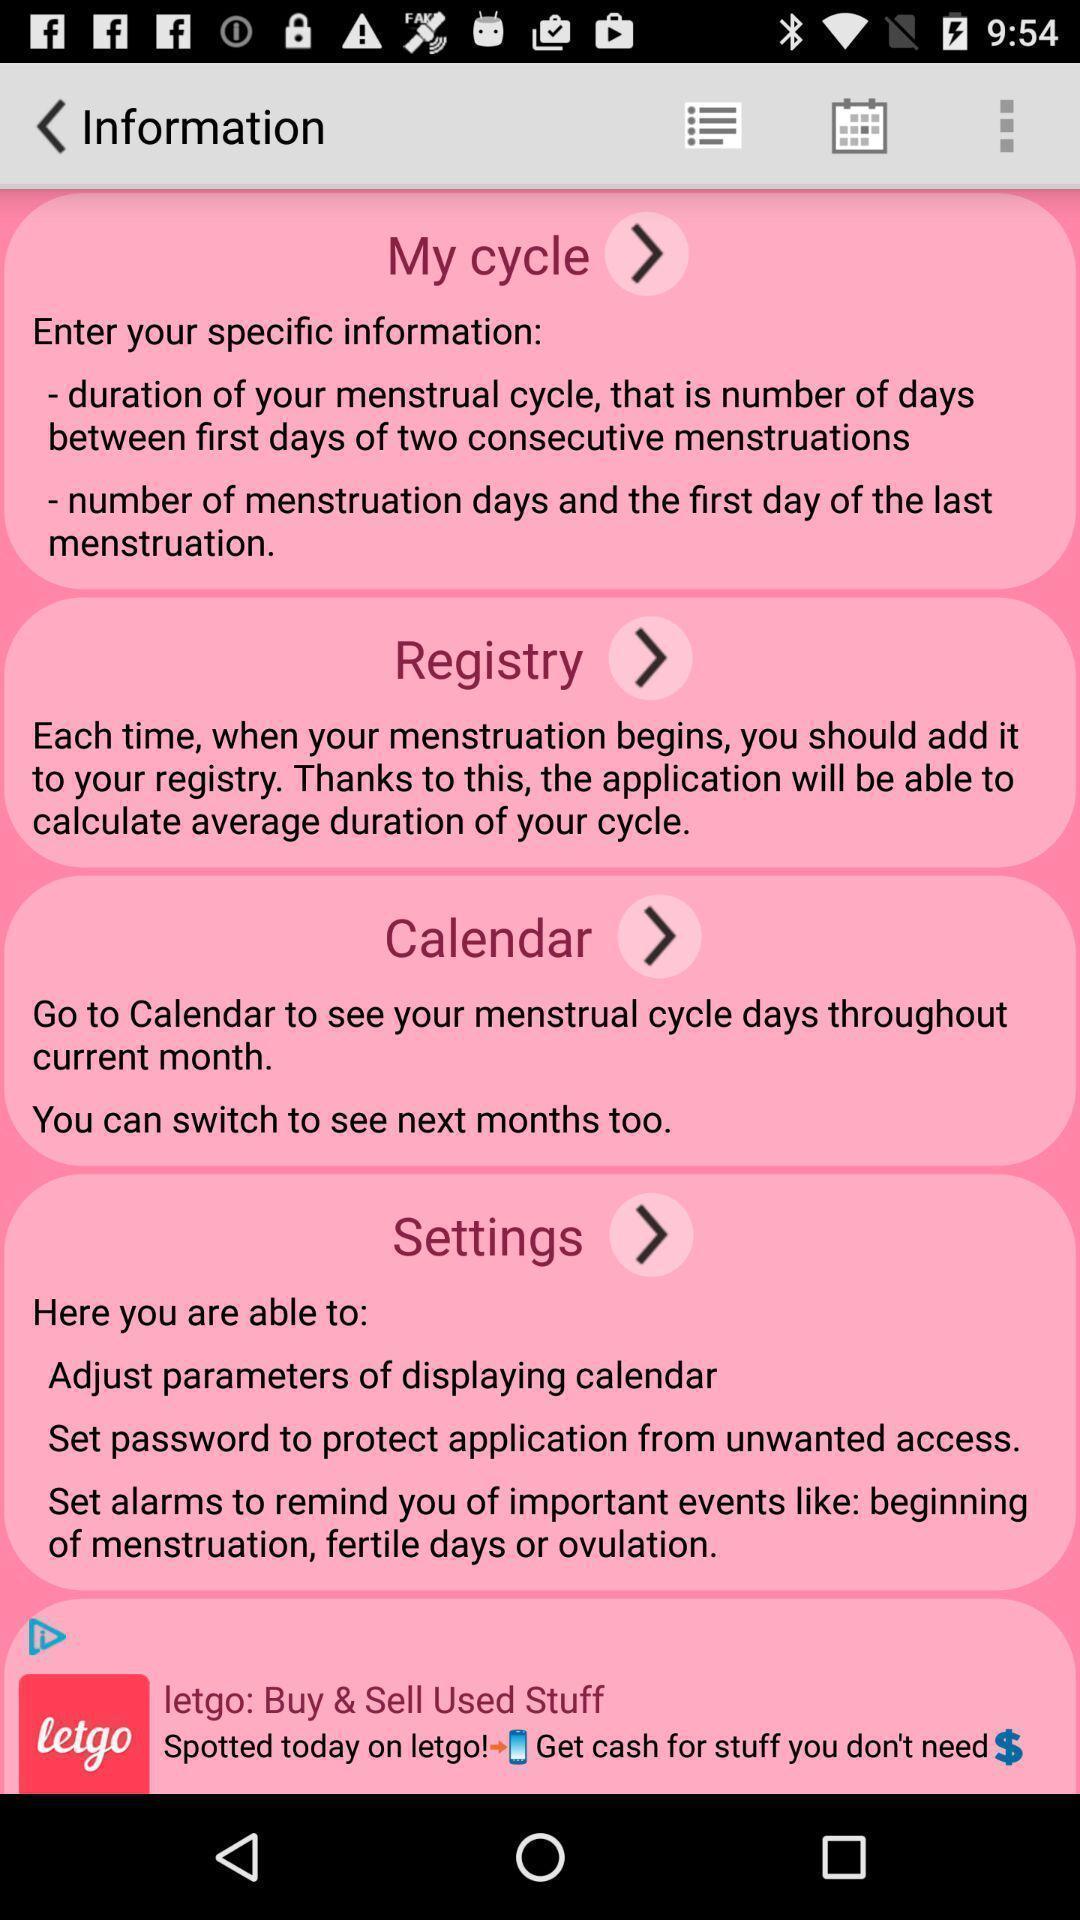Please provide a description for this image. Page is about the information of menstruation app. 